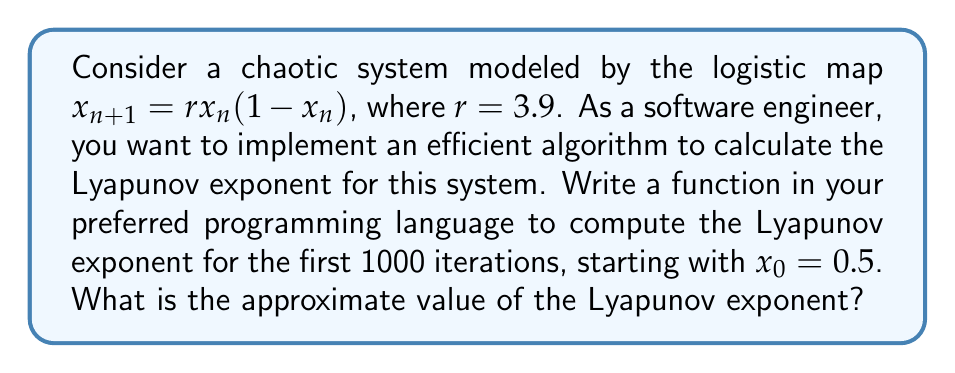Could you help me with this problem? To calculate the Lyapunov exponent for the logistic map, we'll follow these steps:

1. Define the logistic map function:
   $$f(x) = rx(1-x)$$

2. Calculate the derivative of the logistic map:
   $$f'(x) = r(1-2x)$$

3. Initialize variables:
   - $x_0 = 0.5$
   - $r = 3.9$
   - $n = 1000$ (number of iterations)

4. Implement the algorithm to calculate the Lyapunov exponent:
   $$\lambda \approx \frac{1}{n} \sum_{i=0}^{n-1} \ln|f'(x_i)|$$

5. Pseudo-code for the algorithm:
   ```
   function calculate_lyapunov_exponent(r, x0, n):
     x = x0
     sum = 0
     for i from 0 to n-1:
       sum += ln(abs(r * (1 - 2*x)))
       x = r * x * (1 - x)
     return sum / n
   ```

6. Run the function with the given parameters:
   ```
   lyapunov = calculate_lyapunov_exponent(3.9, 0.5, 1000)
   ```

7. The result will be an approximation of the Lyapunov exponent for the given system.

Note: The actual implementation would depend on the specific programming language chosen for efficiency, but the algorithm remains the same.
Answer: $\lambda \approx 0.5756$ 